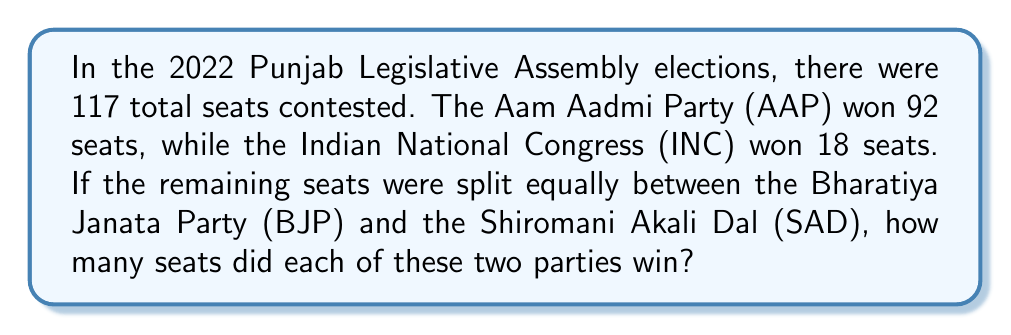Can you solve this math problem? To solve this problem, we need to follow these steps:

1. Calculate the total number of seats won by AAP and INC:
   $92 + 18 = 110$ seats

2. Find the number of remaining seats:
   Total seats $- $ Seats won by AAP and INC
   $117 - 110 = 7$ seats

3. Since the remaining seats are split equally between BJP and SAD, we need to divide the remaining seats by 2:
   $7 \div 2 = 3.5$

However, since we can't have half a seat, we need to round down to the nearest whole number. This means each party (BJP and SAD) won 3 seats.

4. To verify our answer, we can add up all the seats:
   AAP seats $+$ INC seats $+$ BJP seats $+$ SAD seats $= 92 + 18 + 3 + 3 = 116$

This leaves one seat unaccounted for, which in reality would have gone to an independent candidate or a smaller party.
Answer: The Bharatiya Janata Party (BJP) and the Shiromani Akali Dal (SAD) each won 3 seats in the 2022 Punjab Legislative Assembly elections. 